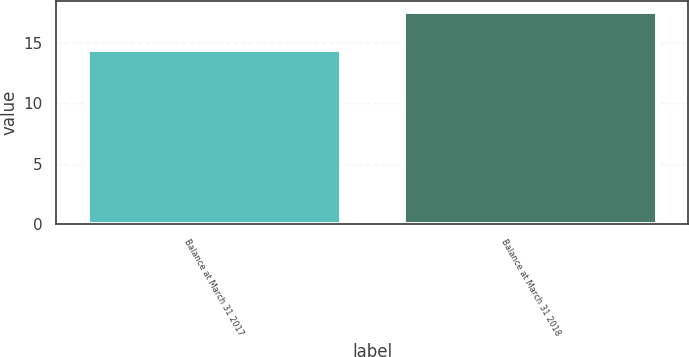Convert chart. <chart><loc_0><loc_0><loc_500><loc_500><bar_chart><fcel>Balance at March 31 2017<fcel>Balance at March 31 2018<nl><fcel>14.4<fcel>17.6<nl></chart> 